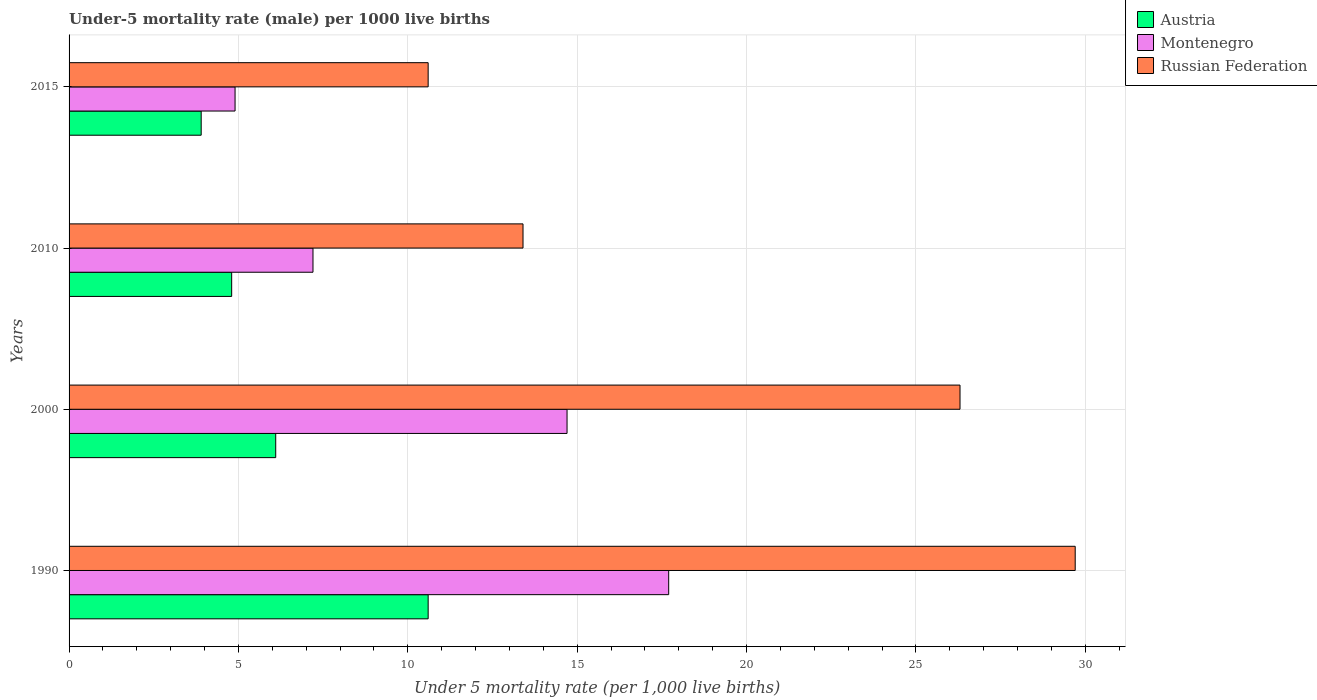How many different coloured bars are there?
Your answer should be very brief. 3. Are the number of bars per tick equal to the number of legend labels?
Ensure brevity in your answer.  Yes. In how many cases, is the number of bars for a given year not equal to the number of legend labels?
Your answer should be compact. 0. What is the under-five mortality rate in Austria in 1990?
Provide a succinct answer. 10.6. Across all years, what is the maximum under-five mortality rate in Russian Federation?
Ensure brevity in your answer.  29.7. Across all years, what is the minimum under-five mortality rate in Austria?
Offer a very short reply. 3.9. In which year was the under-five mortality rate in Russian Federation maximum?
Ensure brevity in your answer.  1990. In which year was the under-five mortality rate in Russian Federation minimum?
Make the answer very short. 2015. What is the total under-five mortality rate in Austria in the graph?
Provide a short and direct response. 25.4. What is the difference between the under-five mortality rate in Austria in 1990 and that in 2010?
Provide a short and direct response. 5.8. What is the ratio of the under-five mortality rate in Russian Federation in 1990 to that in 2015?
Offer a terse response. 2.8. Is the under-five mortality rate in Montenegro in 2000 less than that in 2010?
Provide a short and direct response. No. What is the difference between the highest and the second highest under-five mortality rate in Russian Federation?
Make the answer very short. 3.4. What is the difference between the highest and the lowest under-five mortality rate in Montenegro?
Your answer should be compact. 12.8. In how many years, is the under-five mortality rate in Montenegro greater than the average under-five mortality rate in Montenegro taken over all years?
Your response must be concise. 2. What does the 3rd bar from the bottom in 1990 represents?
Ensure brevity in your answer.  Russian Federation. Is it the case that in every year, the sum of the under-five mortality rate in Montenegro and under-five mortality rate in Austria is greater than the under-five mortality rate in Russian Federation?
Your response must be concise. No. How many bars are there?
Your response must be concise. 12. Are all the bars in the graph horizontal?
Your answer should be compact. Yes. What is the difference between two consecutive major ticks on the X-axis?
Keep it short and to the point. 5. Are the values on the major ticks of X-axis written in scientific E-notation?
Offer a very short reply. No. Does the graph contain grids?
Ensure brevity in your answer.  Yes. Where does the legend appear in the graph?
Your answer should be compact. Top right. How are the legend labels stacked?
Your answer should be compact. Vertical. What is the title of the graph?
Your answer should be very brief. Under-5 mortality rate (male) per 1000 live births. What is the label or title of the X-axis?
Your answer should be compact. Under 5 mortality rate (per 1,0 live births). What is the label or title of the Y-axis?
Give a very brief answer. Years. What is the Under 5 mortality rate (per 1,000 live births) in Montenegro in 1990?
Keep it short and to the point. 17.7. What is the Under 5 mortality rate (per 1,000 live births) of Russian Federation in 1990?
Keep it short and to the point. 29.7. What is the Under 5 mortality rate (per 1,000 live births) in Austria in 2000?
Ensure brevity in your answer.  6.1. What is the Under 5 mortality rate (per 1,000 live births) of Russian Federation in 2000?
Provide a short and direct response. 26.3. What is the Under 5 mortality rate (per 1,000 live births) of Austria in 2010?
Your answer should be compact. 4.8. What is the Under 5 mortality rate (per 1,000 live births) of Montenegro in 2015?
Offer a very short reply. 4.9. Across all years, what is the maximum Under 5 mortality rate (per 1,000 live births) in Montenegro?
Your response must be concise. 17.7. Across all years, what is the maximum Under 5 mortality rate (per 1,000 live births) of Russian Federation?
Offer a very short reply. 29.7. Across all years, what is the minimum Under 5 mortality rate (per 1,000 live births) of Austria?
Provide a succinct answer. 3.9. Across all years, what is the minimum Under 5 mortality rate (per 1,000 live births) of Montenegro?
Give a very brief answer. 4.9. Across all years, what is the minimum Under 5 mortality rate (per 1,000 live births) of Russian Federation?
Offer a very short reply. 10.6. What is the total Under 5 mortality rate (per 1,000 live births) of Austria in the graph?
Offer a very short reply. 25.4. What is the total Under 5 mortality rate (per 1,000 live births) in Montenegro in the graph?
Keep it short and to the point. 44.5. What is the total Under 5 mortality rate (per 1,000 live births) of Russian Federation in the graph?
Ensure brevity in your answer.  80. What is the difference between the Under 5 mortality rate (per 1,000 live births) in Austria in 1990 and that in 2000?
Keep it short and to the point. 4.5. What is the difference between the Under 5 mortality rate (per 1,000 live births) of Russian Federation in 1990 and that in 2000?
Your answer should be very brief. 3.4. What is the difference between the Under 5 mortality rate (per 1,000 live births) in Austria in 1990 and that in 2010?
Offer a terse response. 5.8. What is the difference between the Under 5 mortality rate (per 1,000 live births) in Montenegro in 1990 and that in 2010?
Your response must be concise. 10.5. What is the difference between the Under 5 mortality rate (per 1,000 live births) in Austria in 2000 and that in 2010?
Keep it short and to the point. 1.3. What is the difference between the Under 5 mortality rate (per 1,000 live births) in Russian Federation in 2000 and that in 2010?
Make the answer very short. 12.9. What is the difference between the Under 5 mortality rate (per 1,000 live births) of Austria in 2000 and that in 2015?
Offer a terse response. 2.2. What is the difference between the Under 5 mortality rate (per 1,000 live births) in Montenegro in 2000 and that in 2015?
Keep it short and to the point. 9.8. What is the difference between the Under 5 mortality rate (per 1,000 live births) of Austria in 2010 and that in 2015?
Provide a succinct answer. 0.9. What is the difference between the Under 5 mortality rate (per 1,000 live births) of Montenegro in 2010 and that in 2015?
Make the answer very short. 2.3. What is the difference between the Under 5 mortality rate (per 1,000 live births) in Austria in 1990 and the Under 5 mortality rate (per 1,000 live births) in Montenegro in 2000?
Your answer should be compact. -4.1. What is the difference between the Under 5 mortality rate (per 1,000 live births) in Austria in 1990 and the Under 5 mortality rate (per 1,000 live births) in Russian Federation in 2000?
Keep it short and to the point. -15.7. What is the difference between the Under 5 mortality rate (per 1,000 live births) in Austria in 1990 and the Under 5 mortality rate (per 1,000 live births) in Montenegro in 2015?
Make the answer very short. 5.7. What is the difference between the Under 5 mortality rate (per 1,000 live births) in Austria in 1990 and the Under 5 mortality rate (per 1,000 live births) in Russian Federation in 2015?
Your answer should be very brief. 0. What is the difference between the Under 5 mortality rate (per 1,000 live births) of Montenegro in 1990 and the Under 5 mortality rate (per 1,000 live births) of Russian Federation in 2015?
Offer a terse response. 7.1. What is the difference between the Under 5 mortality rate (per 1,000 live births) in Austria in 2000 and the Under 5 mortality rate (per 1,000 live births) in Russian Federation in 2010?
Keep it short and to the point. -7.3. What is the difference between the Under 5 mortality rate (per 1,000 live births) in Austria in 2000 and the Under 5 mortality rate (per 1,000 live births) in Montenegro in 2015?
Offer a terse response. 1.2. What is the difference between the Under 5 mortality rate (per 1,000 live births) in Austria in 2000 and the Under 5 mortality rate (per 1,000 live births) in Russian Federation in 2015?
Keep it short and to the point. -4.5. What is the difference between the Under 5 mortality rate (per 1,000 live births) of Montenegro in 2000 and the Under 5 mortality rate (per 1,000 live births) of Russian Federation in 2015?
Ensure brevity in your answer.  4.1. What is the difference between the Under 5 mortality rate (per 1,000 live births) of Austria in 2010 and the Under 5 mortality rate (per 1,000 live births) of Russian Federation in 2015?
Make the answer very short. -5.8. What is the difference between the Under 5 mortality rate (per 1,000 live births) of Montenegro in 2010 and the Under 5 mortality rate (per 1,000 live births) of Russian Federation in 2015?
Give a very brief answer. -3.4. What is the average Under 5 mortality rate (per 1,000 live births) in Austria per year?
Provide a short and direct response. 6.35. What is the average Under 5 mortality rate (per 1,000 live births) in Montenegro per year?
Keep it short and to the point. 11.12. What is the average Under 5 mortality rate (per 1,000 live births) of Russian Federation per year?
Your response must be concise. 20. In the year 1990, what is the difference between the Under 5 mortality rate (per 1,000 live births) in Austria and Under 5 mortality rate (per 1,000 live births) in Russian Federation?
Your response must be concise. -19.1. In the year 1990, what is the difference between the Under 5 mortality rate (per 1,000 live births) in Montenegro and Under 5 mortality rate (per 1,000 live births) in Russian Federation?
Make the answer very short. -12. In the year 2000, what is the difference between the Under 5 mortality rate (per 1,000 live births) of Austria and Under 5 mortality rate (per 1,000 live births) of Montenegro?
Offer a very short reply. -8.6. In the year 2000, what is the difference between the Under 5 mortality rate (per 1,000 live births) of Austria and Under 5 mortality rate (per 1,000 live births) of Russian Federation?
Offer a terse response. -20.2. In the year 2010, what is the difference between the Under 5 mortality rate (per 1,000 live births) of Montenegro and Under 5 mortality rate (per 1,000 live births) of Russian Federation?
Ensure brevity in your answer.  -6.2. What is the ratio of the Under 5 mortality rate (per 1,000 live births) in Austria in 1990 to that in 2000?
Keep it short and to the point. 1.74. What is the ratio of the Under 5 mortality rate (per 1,000 live births) in Montenegro in 1990 to that in 2000?
Give a very brief answer. 1.2. What is the ratio of the Under 5 mortality rate (per 1,000 live births) of Russian Federation in 1990 to that in 2000?
Provide a succinct answer. 1.13. What is the ratio of the Under 5 mortality rate (per 1,000 live births) in Austria in 1990 to that in 2010?
Your answer should be compact. 2.21. What is the ratio of the Under 5 mortality rate (per 1,000 live births) in Montenegro in 1990 to that in 2010?
Ensure brevity in your answer.  2.46. What is the ratio of the Under 5 mortality rate (per 1,000 live births) in Russian Federation in 1990 to that in 2010?
Provide a short and direct response. 2.22. What is the ratio of the Under 5 mortality rate (per 1,000 live births) of Austria in 1990 to that in 2015?
Ensure brevity in your answer.  2.72. What is the ratio of the Under 5 mortality rate (per 1,000 live births) in Montenegro in 1990 to that in 2015?
Offer a very short reply. 3.61. What is the ratio of the Under 5 mortality rate (per 1,000 live births) of Russian Federation in 1990 to that in 2015?
Provide a succinct answer. 2.8. What is the ratio of the Under 5 mortality rate (per 1,000 live births) in Austria in 2000 to that in 2010?
Offer a very short reply. 1.27. What is the ratio of the Under 5 mortality rate (per 1,000 live births) of Montenegro in 2000 to that in 2010?
Provide a short and direct response. 2.04. What is the ratio of the Under 5 mortality rate (per 1,000 live births) in Russian Federation in 2000 to that in 2010?
Your answer should be compact. 1.96. What is the ratio of the Under 5 mortality rate (per 1,000 live births) in Austria in 2000 to that in 2015?
Provide a short and direct response. 1.56. What is the ratio of the Under 5 mortality rate (per 1,000 live births) of Russian Federation in 2000 to that in 2015?
Your response must be concise. 2.48. What is the ratio of the Under 5 mortality rate (per 1,000 live births) of Austria in 2010 to that in 2015?
Provide a short and direct response. 1.23. What is the ratio of the Under 5 mortality rate (per 1,000 live births) in Montenegro in 2010 to that in 2015?
Your answer should be compact. 1.47. What is the ratio of the Under 5 mortality rate (per 1,000 live births) in Russian Federation in 2010 to that in 2015?
Provide a short and direct response. 1.26. What is the difference between the highest and the second highest Under 5 mortality rate (per 1,000 live births) in Austria?
Ensure brevity in your answer.  4.5. What is the difference between the highest and the second highest Under 5 mortality rate (per 1,000 live births) of Montenegro?
Make the answer very short. 3. What is the difference between the highest and the second highest Under 5 mortality rate (per 1,000 live births) of Russian Federation?
Your answer should be compact. 3.4. What is the difference between the highest and the lowest Under 5 mortality rate (per 1,000 live births) of Austria?
Give a very brief answer. 6.7. What is the difference between the highest and the lowest Under 5 mortality rate (per 1,000 live births) in Russian Federation?
Your answer should be compact. 19.1. 